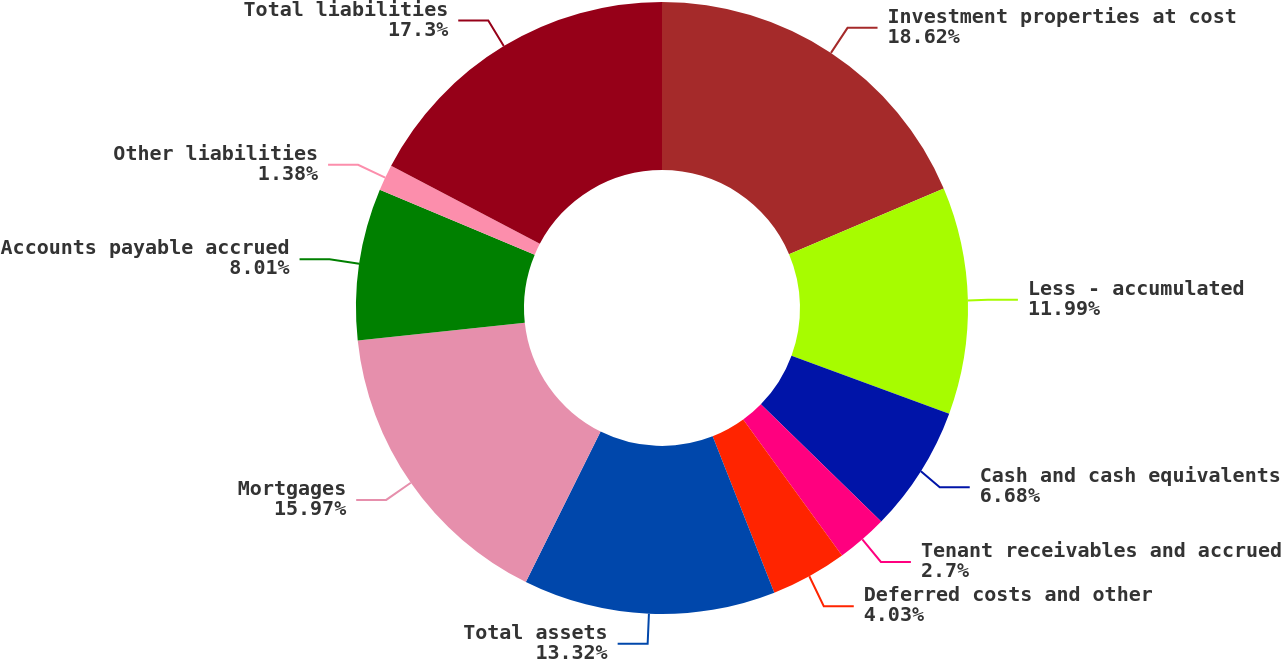<chart> <loc_0><loc_0><loc_500><loc_500><pie_chart><fcel>Investment properties at cost<fcel>Less - accumulated<fcel>Cash and cash equivalents<fcel>Tenant receivables and accrued<fcel>Deferred costs and other<fcel>Total assets<fcel>Mortgages<fcel>Accounts payable accrued<fcel>Other liabilities<fcel>Total liabilities<nl><fcel>18.62%<fcel>11.99%<fcel>6.68%<fcel>2.7%<fcel>4.03%<fcel>13.32%<fcel>15.97%<fcel>8.01%<fcel>1.38%<fcel>17.3%<nl></chart> 